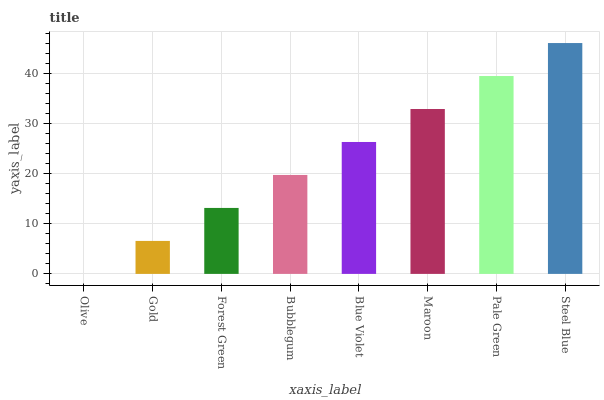Is Gold the minimum?
Answer yes or no. No. Is Gold the maximum?
Answer yes or no. No. Is Gold greater than Olive?
Answer yes or no. Yes. Is Olive less than Gold?
Answer yes or no. Yes. Is Olive greater than Gold?
Answer yes or no. No. Is Gold less than Olive?
Answer yes or no. No. Is Blue Violet the high median?
Answer yes or no. Yes. Is Bubblegum the low median?
Answer yes or no. Yes. Is Steel Blue the high median?
Answer yes or no. No. Is Gold the low median?
Answer yes or no. No. 